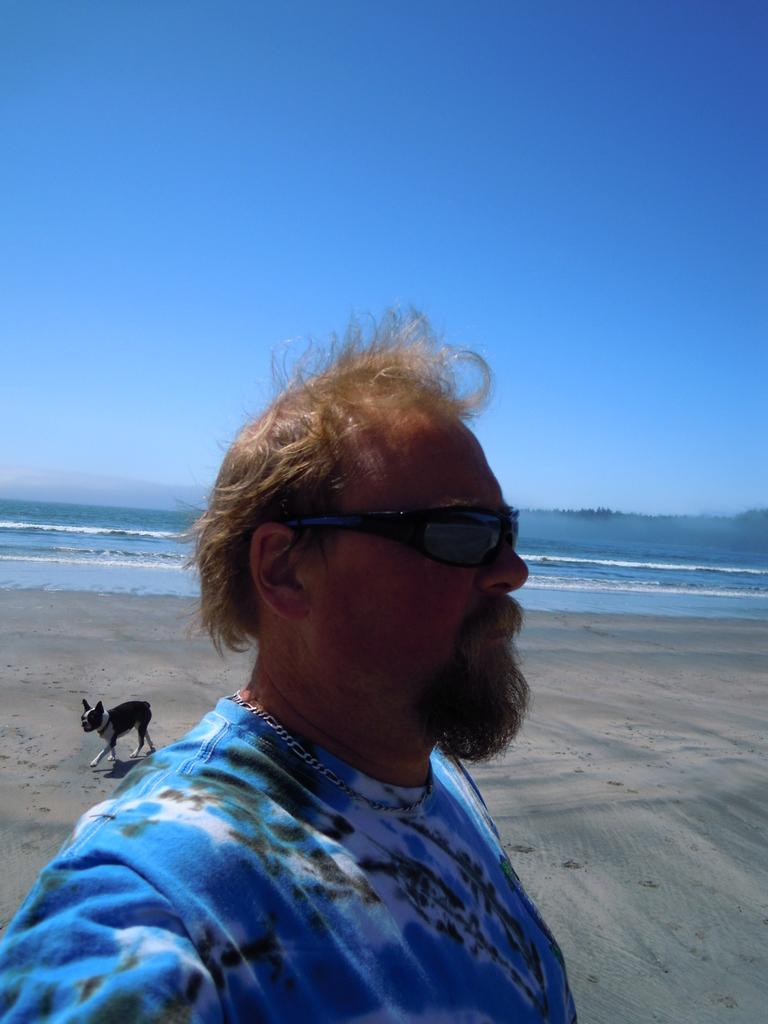What is the main subject of the image? There is a man standing in the image. What is the man wearing in the image? The man is wearing goggles. What type of animal is present in the image? There is a black color dog in the image. What natural element can be seen in the image? Water is visible in the image. What is visible in the background of the image? The sky is visible in the image. How does the man sort the shoes in the image? There are no shoes present in the image, so the man cannot sort any shoes. 